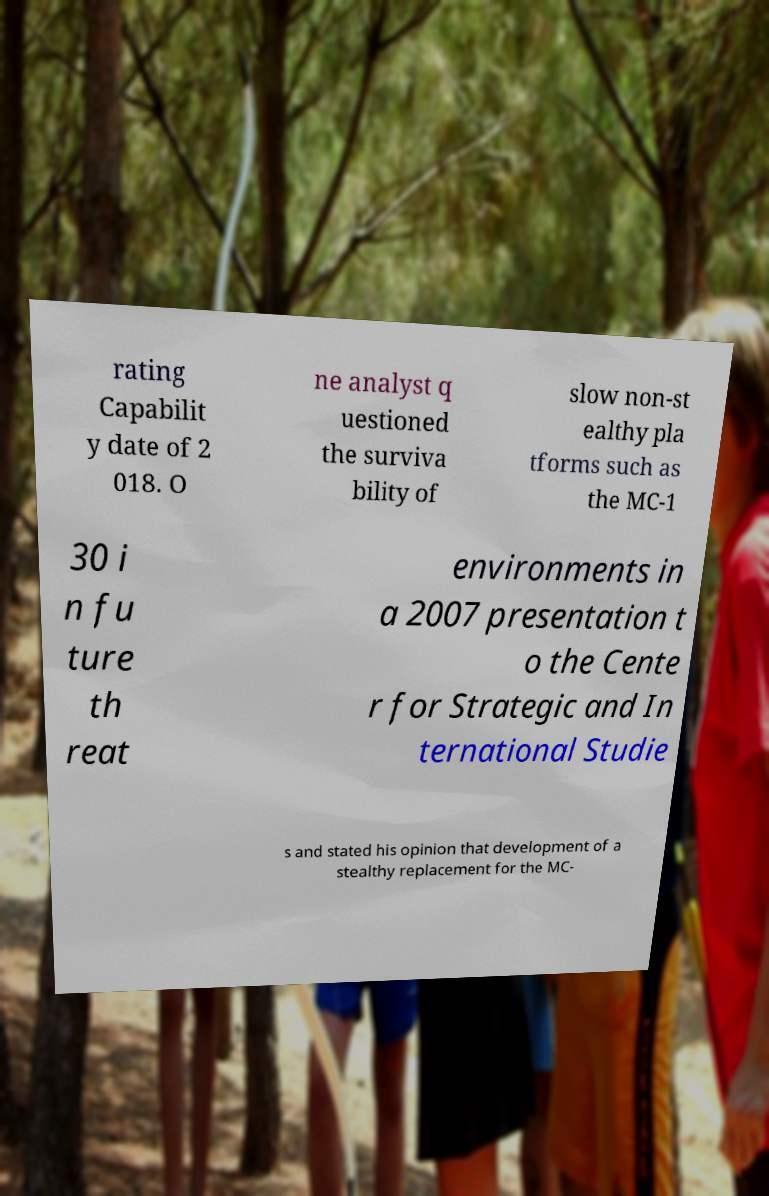Could you extract and type out the text from this image? rating Capabilit y date of 2 018. O ne analyst q uestioned the surviva bility of slow non-st ealthy pla tforms such as the MC-1 30 i n fu ture th reat environments in a 2007 presentation t o the Cente r for Strategic and In ternational Studie s and stated his opinion that development of a stealthy replacement for the MC- 